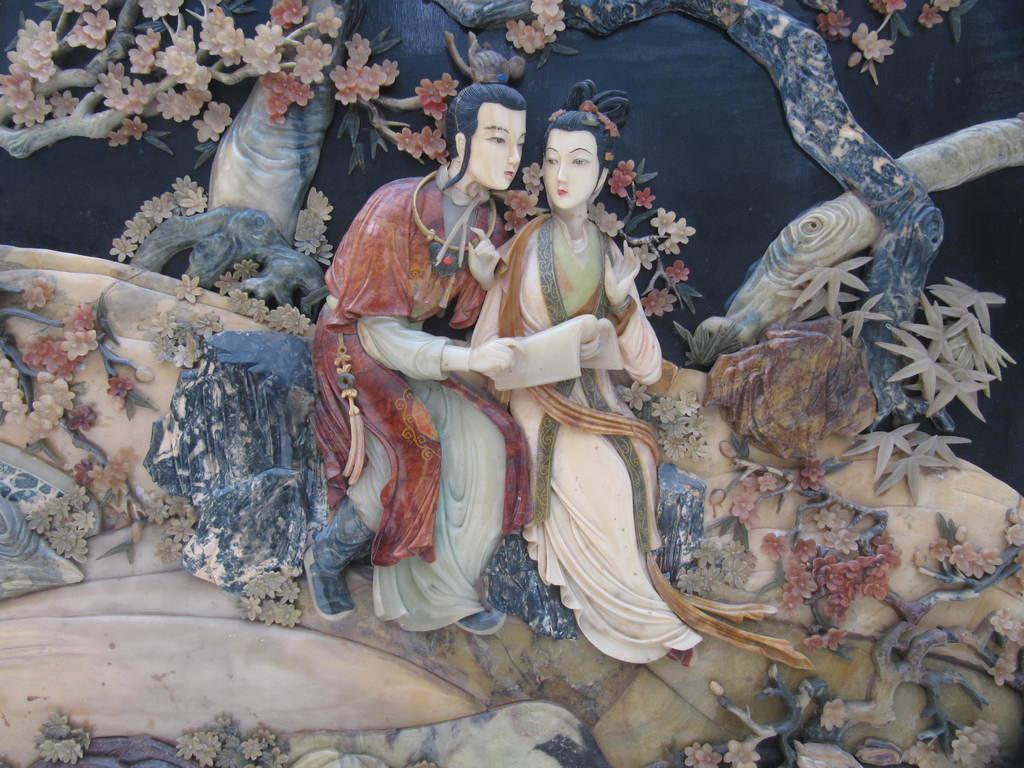What is the main subject of the image? The main subject of the image is a stone carving. What is depicted on the stone carving? There are two members depicted on the stone. What type of natural environment can be seen in the image? There are trees visible in the image. What is the color of the background in the image? The background of the image is in black color. Can you see any rabbits playing with a net near the coast in the image? There are no rabbits, nets, or coastlines present in the image; it features a stone carving with two members and a black background. 